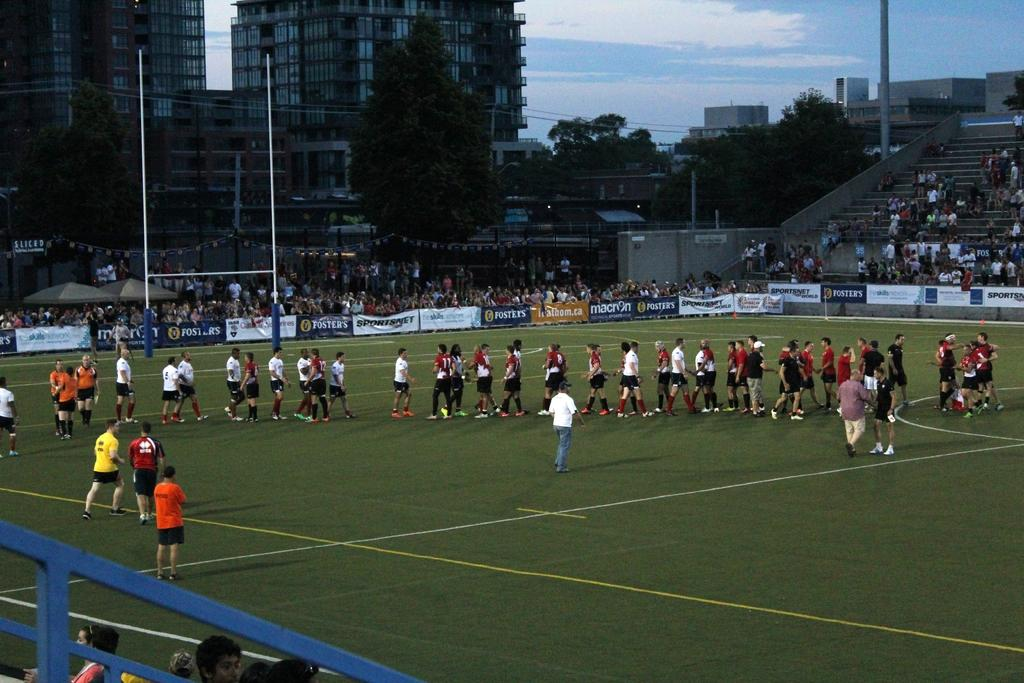How many people are in the image? There are people in the image, but the exact number is not specified. What is the position of the people in the image? The people are on the ground in the image. What can be seen in the background of the image? There are trees, buildings, and the sky visible in the background of the image. What type of noise can be heard coming from the scissors in the image? There are no scissors present in the image, so it is not possible to determine what noise, if any, might be heard. 